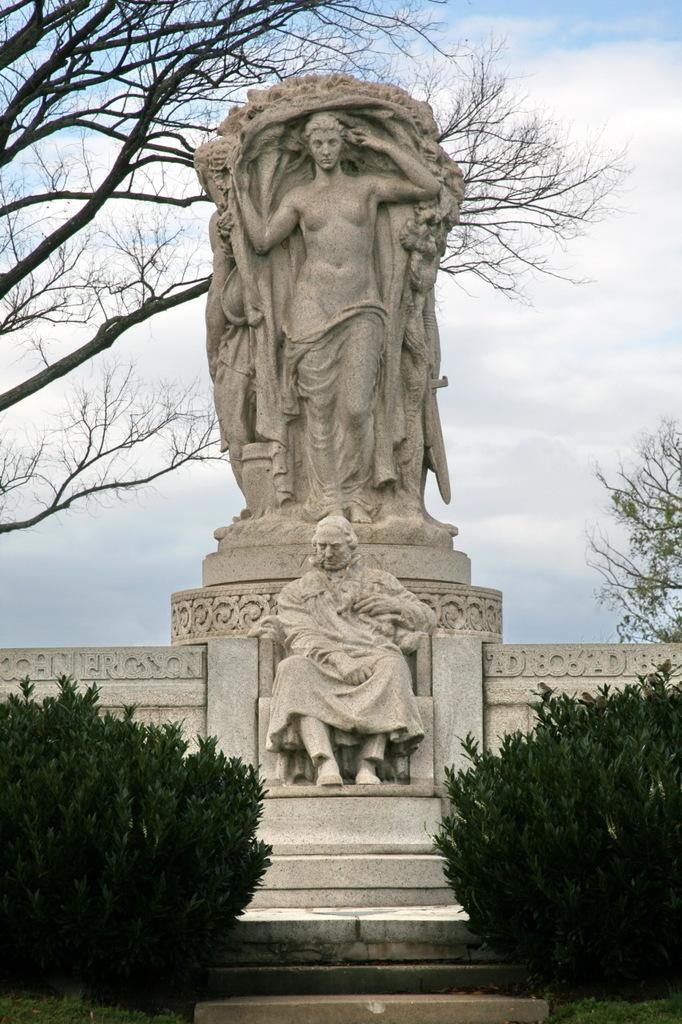How many statues are present in the image? There are two statues in the image. What type of plants can be seen in the image? There are two green color plants in the image. What other natural elements are visible in the image? There are trees in the image. What is visible in the background of the image? The sky is visible in the image. What is the condition of the sky in the image? The sky is cloudy in the image. What type of business is being conducted by the doctor in the image? There is no doctor or business activity present in the image. 